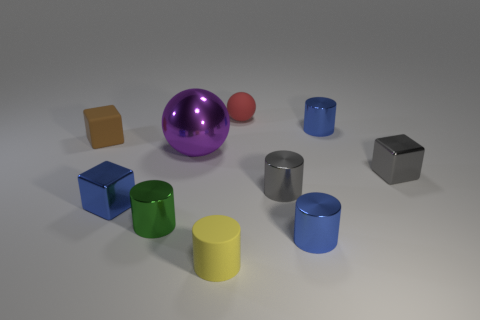The tiny matte cylinder is what color? The small matte-finished cylinder in the image appears to be yellow, displaying a subtle surface texture that differentiates it from the glossier objects nearby. 